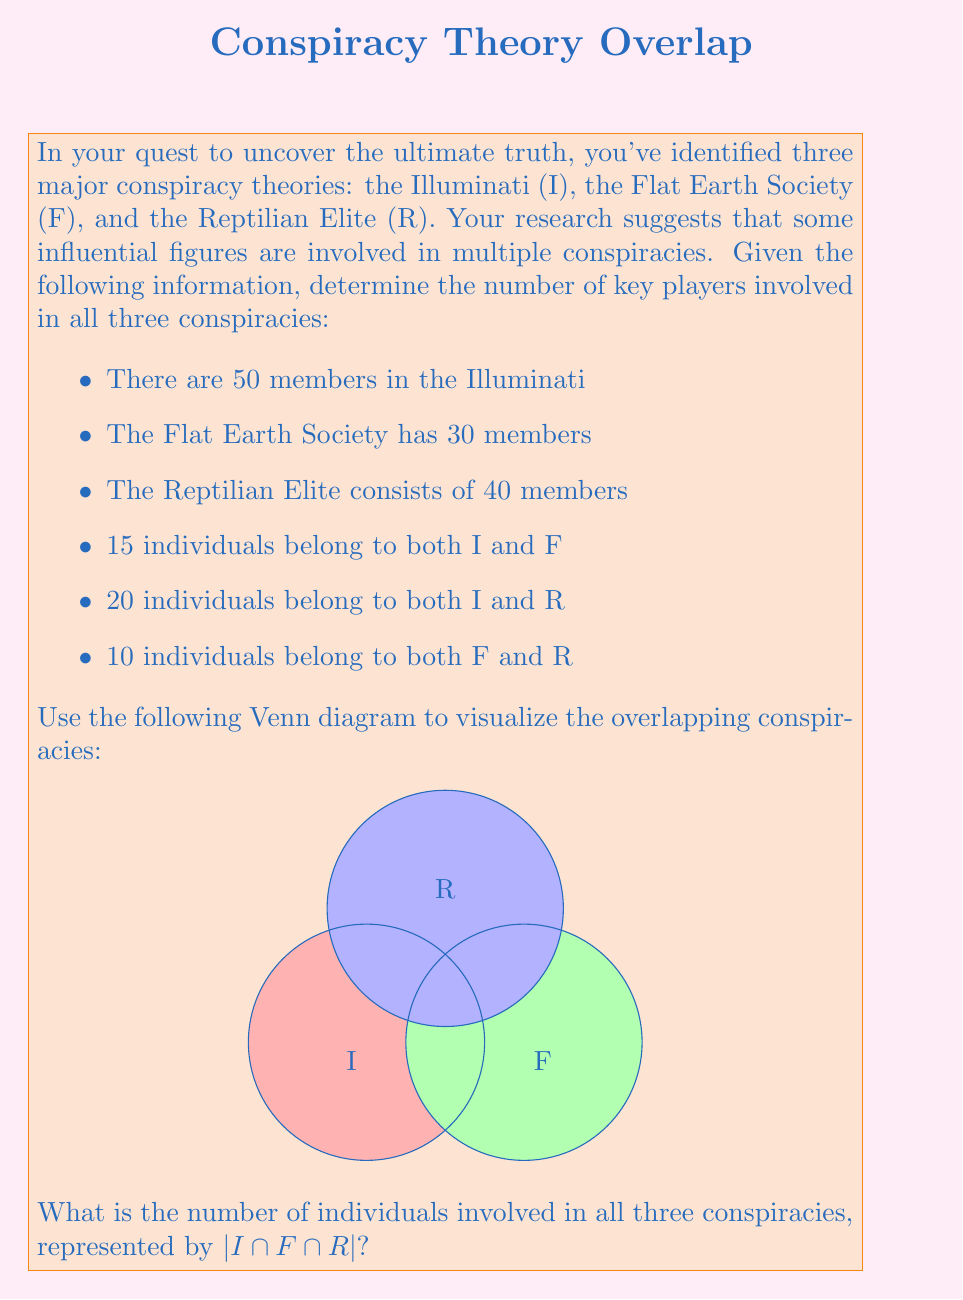Show me your answer to this math problem. To solve this problem, we'll use the principle of inclusion-exclusion for three sets. Let's follow these steps:

1) First, recall the formula for three sets A, B, and C:
   $$|A \cup B \cup C| = |A| + |B| + |C| - |A \cap B| - |A \cap C| - |B \cap C| + |A \cap B \cap C|$$

2) In our case, we want to find $|I \cap F \cap R|$, so we'll rearrange the formula:
   $$|I \cap F \cap R| = |I| + |F| + |R| - |I \cup F \cup R| - |I \cap F| - |I \cap R| - |F \cap R|$$

3) We know:
   $|I| = 50$, $|F| = 30$, $|R| = 40$
   $|I \cap F| = 15$, $|I \cap R| = 20$, $|F \cap R| = 10$

4) We need to find $|I \cup F \cup R|$. Let's use the same formula:
   $$|I \cup F \cup R| = |I| + |F| + |R| - |I \cap F| - |I \cap R| - |F \cap R| + |I \cap F \cap R|$$

5) Substituting the known values:
   $$|I \cup F \cup R| = 50 + 30 + 40 - 15 - 20 - 10 + |I \cap F \cap R|$$

6) Now, let's substitute this into our equation from step 2:
   $$|I \cap F \cap R| = 50 + 30 + 40 - (50 + 30 + 40 - 15 - 20 - 10 + |I \cap F \cap R|) - 15 - 20 - 10$$

7) Simplifying:
   $$|I \cap F \cap R| = 120 - (120 - 45 + |I \cap F \cap R|) - 45$$
   $$|I \cap F \cap R| = 120 - 120 + 45 - |I \cap F \cap R| - 45$$
   $$2|I \cap F \cap R| = 0$$
   $$|I \cap F \cap R| = 0$$

Therefore, there are 0 individuals involved in all three conspiracies.
Answer: 0 